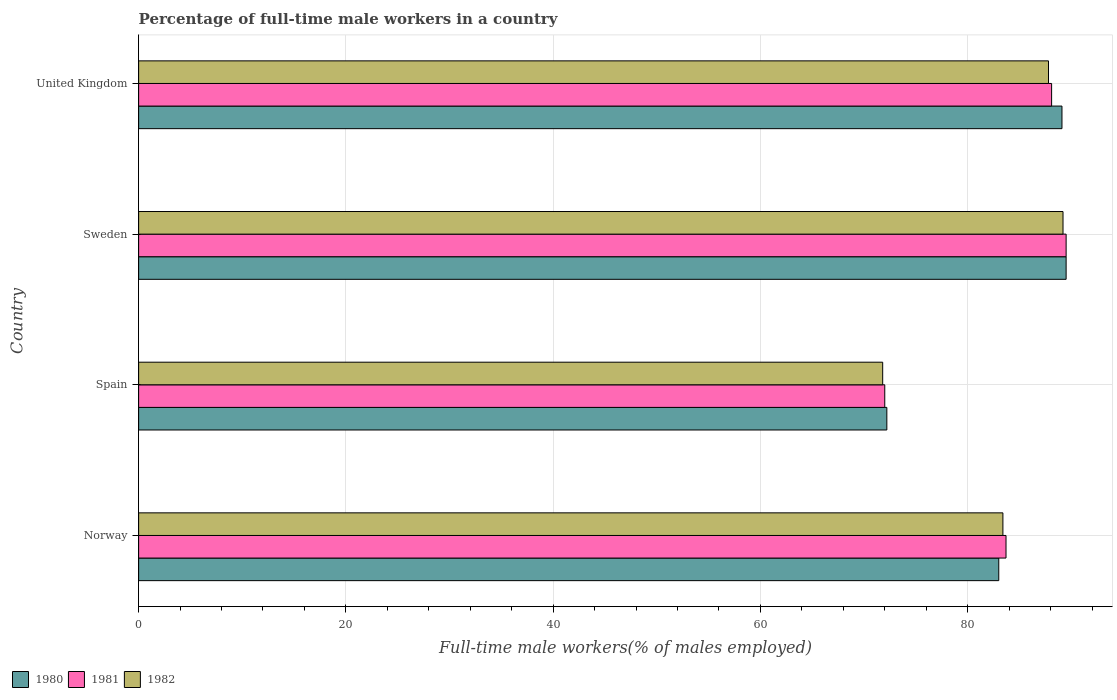How many different coloured bars are there?
Offer a very short reply. 3. Are the number of bars on each tick of the Y-axis equal?
Give a very brief answer. Yes. How many bars are there on the 2nd tick from the bottom?
Provide a succinct answer. 3. In how many cases, is the number of bars for a given country not equal to the number of legend labels?
Provide a succinct answer. 0. What is the percentage of full-time male workers in 1981 in United Kingdom?
Provide a short and direct response. 88.1. Across all countries, what is the maximum percentage of full-time male workers in 1981?
Provide a short and direct response. 89.5. Across all countries, what is the minimum percentage of full-time male workers in 1981?
Provide a short and direct response. 72. In which country was the percentage of full-time male workers in 1982 maximum?
Provide a succinct answer. Sweden. What is the total percentage of full-time male workers in 1980 in the graph?
Your answer should be compact. 333.8. What is the difference between the percentage of full-time male workers in 1982 in Spain and that in Sweden?
Your answer should be very brief. -17.4. What is the average percentage of full-time male workers in 1980 per country?
Give a very brief answer. 83.45. What is the difference between the percentage of full-time male workers in 1981 and percentage of full-time male workers in 1980 in Norway?
Offer a terse response. 0.7. What is the ratio of the percentage of full-time male workers in 1981 in Sweden to that in United Kingdom?
Your answer should be very brief. 1.02. Is the percentage of full-time male workers in 1981 in Norway less than that in Sweden?
Your response must be concise. Yes. What is the difference between the highest and the second highest percentage of full-time male workers in 1981?
Offer a very short reply. 1.4. In how many countries, is the percentage of full-time male workers in 1981 greater than the average percentage of full-time male workers in 1981 taken over all countries?
Give a very brief answer. 3. Is the sum of the percentage of full-time male workers in 1982 in Spain and United Kingdom greater than the maximum percentage of full-time male workers in 1980 across all countries?
Make the answer very short. Yes. What does the 1st bar from the top in Sweden represents?
Ensure brevity in your answer.  1982. What does the 3rd bar from the bottom in Spain represents?
Offer a terse response. 1982. How many bars are there?
Give a very brief answer. 12. Are all the bars in the graph horizontal?
Your response must be concise. Yes. Does the graph contain grids?
Provide a short and direct response. Yes. How many legend labels are there?
Offer a very short reply. 3. How are the legend labels stacked?
Your answer should be compact. Horizontal. What is the title of the graph?
Provide a short and direct response. Percentage of full-time male workers in a country. What is the label or title of the X-axis?
Your answer should be compact. Full-time male workers(% of males employed). What is the Full-time male workers(% of males employed) of 1980 in Norway?
Offer a terse response. 83. What is the Full-time male workers(% of males employed) in 1981 in Norway?
Give a very brief answer. 83.7. What is the Full-time male workers(% of males employed) of 1982 in Norway?
Keep it short and to the point. 83.4. What is the Full-time male workers(% of males employed) in 1980 in Spain?
Provide a succinct answer. 72.2. What is the Full-time male workers(% of males employed) of 1981 in Spain?
Provide a short and direct response. 72. What is the Full-time male workers(% of males employed) of 1982 in Spain?
Provide a succinct answer. 71.8. What is the Full-time male workers(% of males employed) of 1980 in Sweden?
Provide a succinct answer. 89.5. What is the Full-time male workers(% of males employed) of 1981 in Sweden?
Your response must be concise. 89.5. What is the Full-time male workers(% of males employed) of 1982 in Sweden?
Provide a short and direct response. 89.2. What is the Full-time male workers(% of males employed) in 1980 in United Kingdom?
Your response must be concise. 89.1. What is the Full-time male workers(% of males employed) of 1981 in United Kingdom?
Ensure brevity in your answer.  88.1. What is the Full-time male workers(% of males employed) of 1982 in United Kingdom?
Keep it short and to the point. 87.8. Across all countries, what is the maximum Full-time male workers(% of males employed) in 1980?
Make the answer very short. 89.5. Across all countries, what is the maximum Full-time male workers(% of males employed) of 1981?
Provide a succinct answer. 89.5. Across all countries, what is the maximum Full-time male workers(% of males employed) in 1982?
Your response must be concise. 89.2. Across all countries, what is the minimum Full-time male workers(% of males employed) of 1980?
Ensure brevity in your answer.  72.2. Across all countries, what is the minimum Full-time male workers(% of males employed) of 1981?
Offer a terse response. 72. Across all countries, what is the minimum Full-time male workers(% of males employed) in 1982?
Give a very brief answer. 71.8. What is the total Full-time male workers(% of males employed) of 1980 in the graph?
Give a very brief answer. 333.8. What is the total Full-time male workers(% of males employed) in 1981 in the graph?
Give a very brief answer. 333.3. What is the total Full-time male workers(% of males employed) of 1982 in the graph?
Your answer should be compact. 332.2. What is the difference between the Full-time male workers(% of males employed) of 1982 in Norway and that in Spain?
Provide a short and direct response. 11.6. What is the difference between the Full-time male workers(% of males employed) in 1980 in Norway and that in Sweden?
Offer a very short reply. -6.5. What is the difference between the Full-time male workers(% of males employed) in 1981 in Norway and that in United Kingdom?
Provide a succinct answer. -4.4. What is the difference between the Full-time male workers(% of males employed) in 1982 in Norway and that in United Kingdom?
Your answer should be compact. -4.4. What is the difference between the Full-time male workers(% of males employed) in 1980 in Spain and that in Sweden?
Offer a very short reply. -17.3. What is the difference between the Full-time male workers(% of males employed) of 1981 in Spain and that in Sweden?
Your response must be concise. -17.5. What is the difference between the Full-time male workers(% of males employed) of 1982 in Spain and that in Sweden?
Make the answer very short. -17.4. What is the difference between the Full-time male workers(% of males employed) of 1980 in Spain and that in United Kingdom?
Give a very brief answer. -16.9. What is the difference between the Full-time male workers(% of males employed) in 1981 in Spain and that in United Kingdom?
Provide a succinct answer. -16.1. What is the difference between the Full-time male workers(% of males employed) in 1982 in Spain and that in United Kingdom?
Give a very brief answer. -16. What is the difference between the Full-time male workers(% of males employed) in 1980 in Sweden and that in United Kingdom?
Give a very brief answer. 0.4. What is the difference between the Full-time male workers(% of males employed) of 1980 in Norway and the Full-time male workers(% of males employed) of 1982 in Spain?
Your answer should be very brief. 11.2. What is the difference between the Full-time male workers(% of males employed) in 1980 in Norway and the Full-time male workers(% of males employed) in 1981 in Sweden?
Ensure brevity in your answer.  -6.5. What is the difference between the Full-time male workers(% of males employed) in 1980 in Norway and the Full-time male workers(% of males employed) in 1982 in United Kingdom?
Keep it short and to the point. -4.8. What is the difference between the Full-time male workers(% of males employed) of 1980 in Spain and the Full-time male workers(% of males employed) of 1981 in Sweden?
Provide a short and direct response. -17.3. What is the difference between the Full-time male workers(% of males employed) of 1981 in Spain and the Full-time male workers(% of males employed) of 1982 in Sweden?
Offer a terse response. -17.2. What is the difference between the Full-time male workers(% of males employed) in 1980 in Spain and the Full-time male workers(% of males employed) in 1981 in United Kingdom?
Your response must be concise. -15.9. What is the difference between the Full-time male workers(% of males employed) in 1980 in Spain and the Full-time male workers(% of males employed) in 1982 in United Kingdom?
Ensure brevity in your answer.  -15.6. What is the difference between the Full-time male workers(% of males employed) in 1981 in Spain and the Full-time male workers(% of males employed) in 1982 in United Kingdom?
Your answer should be compact. -15.8. What is the difference between the Full-time male workers(% of males employed) in 1980 in Sweden and the Full-time male workers(% of males employed) in 1981 in United Kingdom?
Make the answer very short. 1.4. What is the average Full-time male workers(% of males employed) in 1980 per country?
Ensure brevity in your answer.  83.45. What is the average Full-time male workers(% of males employed) of 1981 per country?
Ensure brevity in your answer.  83.33. What is the average Full-time male workers(% of males employed) in 1982 per country?
Your answer should be compact. 83.05. What is the difference between the Full-time male workers(% of males employed) in 1980 and Full-time male workers(% of males employed) in 1982 in Norway?
Your answer should be compact. -0.4. What is the difference between the Full-time male workers(% of males employed) of 1981 and Full-time male workers(% of males employed) of 1982 in Norway?
Offer a terse response. 0.3. What is the difference between the Full-time male workers(% of males employed) of 1981 and Full-time male workers(% of males employed) of 1982 in Spain?
Make the answer very short. 0.2. What is the difference between the Full-time male workers(% of males employed) of 1980 and Full-time male workers(% of males employed) of 1981 in Sweden?
Provide a succinct answer. 0. What is the difference between the Full-time male workers(% of males employed) of 1980 and Full-time male workers(% of males employed) of 1982 in Sweden?
Offer a terse response. 0.3. What is the difference between the Full-time male workers(% of males employed) of 1981 and Full-time male workers(% of males employed) of 1982 in Sweden?
Provide a short and direct response. 0.3. What is the difference between the Full-time male workers(% of males employed) in 1980 and Full-time male workers(% of males employed) in 1981 in United Kingdom?
Offer a very short reply. 1. What is the difference between the Full-time male workers(% of males employed) in 1980 and Full-time male workers(% of males employed) in 1982 in United Kingdom?
Make the answer very short. 1.3. What is the difference between the Full-time male workers(% of males employed) of 1981 and Full-time male workers(% of males employed) of 1982 in United Kingdom?
Offer a terse response. 0.3. What is the ratio of the Full-time male workers(% of males employed) in 1980 in Norway to that in Spain?
Offer a very short reply. 1.15. What is the ratio of the Full-time male workers(% of males employed) of 1981 in Norway to that in Spain?
Your answer should be very brief. 1.16. What is the ratio of the Full-time male workers(% of males employed) in 1982 in Norway to that in Spain?
Offer a very short reply. 1.16. What is the ratio of the Full-time male workers(% of males employed) of 1980 in Norway to that in Sweden?
Offer a terse response. 0.93. What is the ratio of the Full-time male workers(% of males employed) in 1981 in Norway to that in Sweden?
Make the answer very short. 0.94. What is the ratio of the Full-time male workers(% of males employed) in 1982 in Norway to that in Sweden?
Provide a short and direct response. 0.94. What is the ratio of the Full-time male workers(% of males employed) of 1980 in Norway to that in United Kingdom?
Make the answer very short. 0.93. What is the ratio of the Full-time male workers(% of males employed) of 1981 in Norway to that in United Kingdom?
Your answer should be compact. 0.95. What is the ratio of the Full-time male workers(% of males employed) in 1982 in Norway to that in United Kingdom?
Offer a terse response. 0.95. What is the ratio of the Full-time male workers(% of males employed) of 1980 in Spain to that in Sweden?
Give a very brief answer. 0.81. What is the ratio of the Full-time male workers(% of males employed) in 1981 in Spain to that in Sweden?
Offer a terse response. 0.8. What is the ratio of the Full-time male workers(% of males employed) of 1982 in Spain to that in Sweden?
Your answer should be compact. 0.8. What is the ratio of the Full-time male workers(% of males employed) in 1980 in Spain to that in United Kingdom?
Your response must be concise. 0.81. What is the ratio of the Full-time male workers(% of males employed) of 1981 in Spain to that in United Kingdom?
Your response must be concise. 0.82. What is the ratio of the Full-time male workers(% of males employed) in 1982 in Spain to that in United Kingdom?
Ensure brevity in your answer.  0.82. What is the ratio of the Full-time male workers(% of males employed) of 1981 in Sweden to that in United Kingdom?
Your response must be concise. 1.02. What is the ratio of the Full-time male workers(% of males employed) of 1982 in Sweden to that in United Kingdom?
Provide a succinct answer. 1.02. What is the difference between the highest and the second highest Full-time male workers(% of males employed) of 1982?
Provide a succinct answer. 1.4. What is the difference between the highest and the lowest Full-time male workers(% of males employed) of 1980?
Ensure brevity in your answer.  17.3. What is the difference between the highest and the lowest Full-time male workers(% of males employed) of 1981?
Keep it short and to the point. 17.5. 